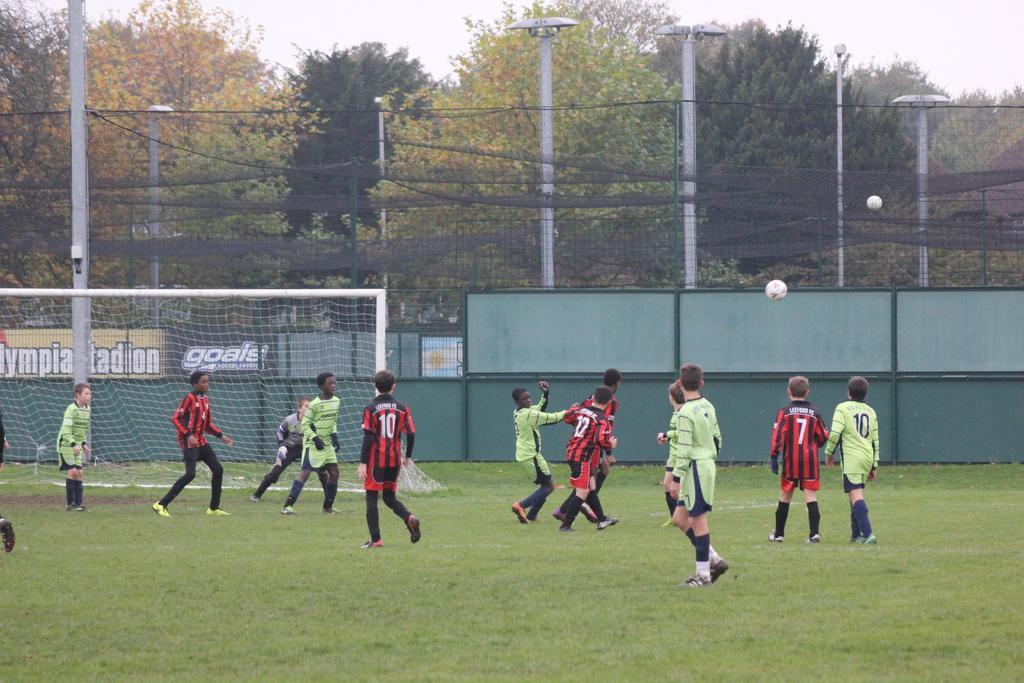Can you describe this image briefly? In this picture I can see few people playing football on the ground. I can see goal post and few boards with some text and I can see poles, trees and a cloudy sky in the background. 